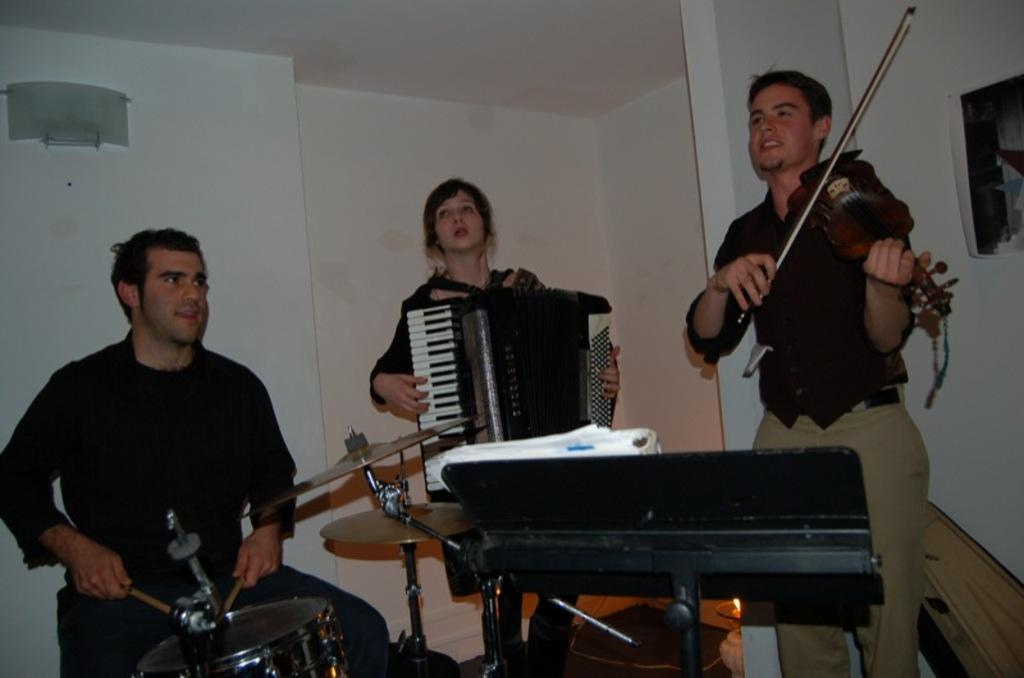How many people are playing musical instruments in the image? There are three persons playing musical instruments in the image. Can you describe the clothing of one of the persons? One person is wearing a black shirt and cream pants. What color is the background wall in the image? The background wall is white. How are the instruments being sorted in the image? There is no indication in the image that the instruments are being sorted. What type of feeling is being expressed by the person wearing the black shirt and cream pants? The image does not show any facial expressions or body language that would indicate a specific feeling. 